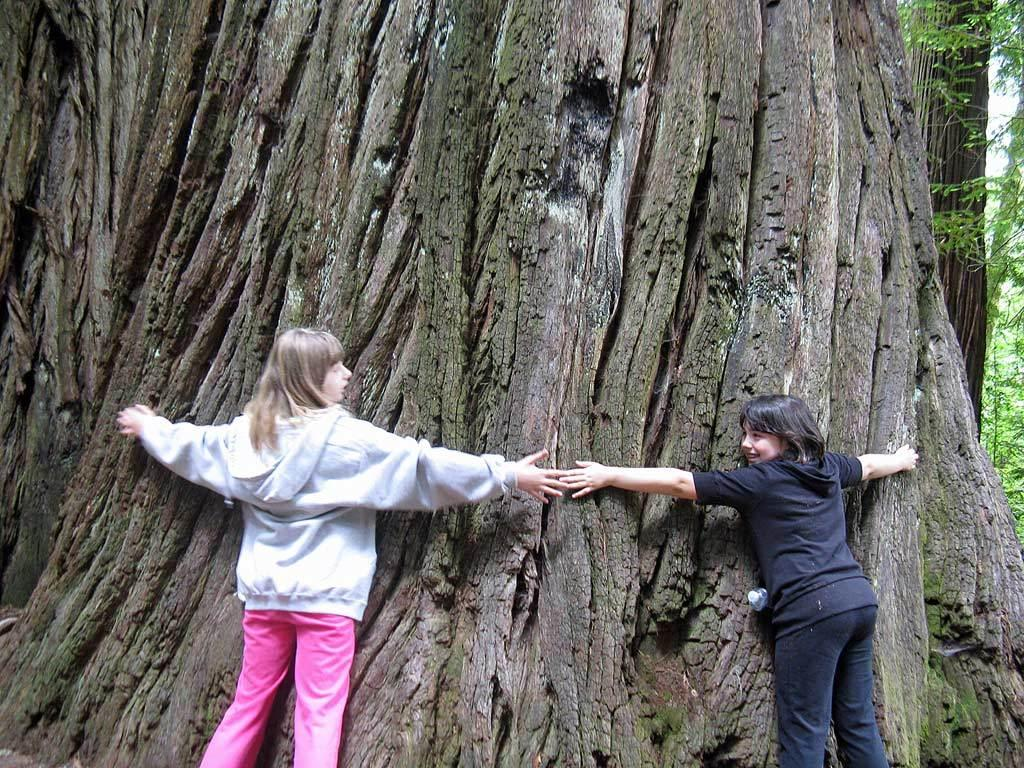How many people are in the image? There are a few people in the image. What can be seen at the base of the trees in the image? The trunks of trees are visible in the image. Where are the trees located in the image? The trees are on the right side of the image. What type of underwear is hanging on the trees in the image? There is no underwear present in the image; only trees and people are visible. 